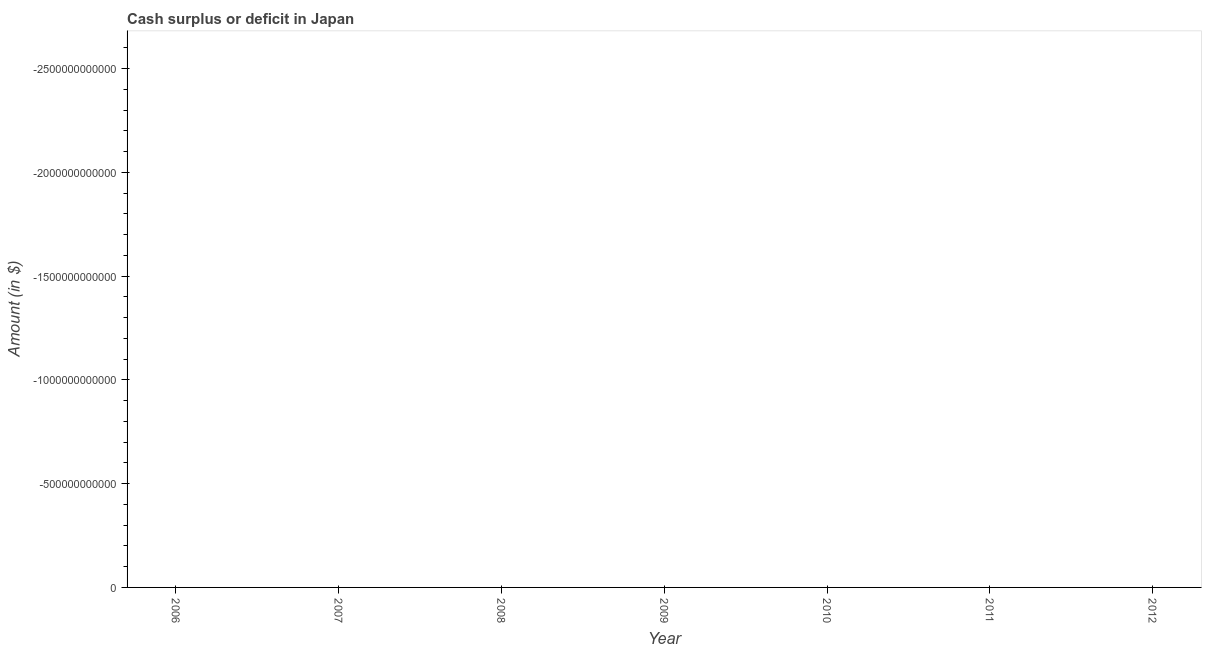Across all years, what is the minimum cash surplus or deficit?
Give a very brief answer. 0. What is the sum of the cash surplus or deficit?
Provide a short and direct response. 0. What is the average cash surplus or deficit per year?
Provide a succinct answer. 0. What is the median cash surplus or deficit?
Offer a very short reply. 0. In how many years, is the cash surplus or deficit greater than the average cash surplus or deficit taken over all years?
Ensure brevity in your answer.  0. How many years are there in the graph?
Your answer should be compact. 7. What is the difference between two consecutive major ticks on the Y-axis?
Provide a succinct answer. 5.00e+11. Are the values on the major ticks of Y-axis written in scientific E-notation?
Give a very brief answer. No. Does the graph contain grids?
Offer a very short reply. No. What is the title of the graph?
Make the answer very short. Cash surplus or deficit in Japan. What is the label or title of the Y-axis?
Your response must be concise. Amount (in $). What is the Amount (in $) in 2006?
Offer a terse response. 0. What is the Amount (in $) of 2009?
Your answer should be compact. 0. What is the Amount (in $) of 2011?
Your answer should be compact. 0. 